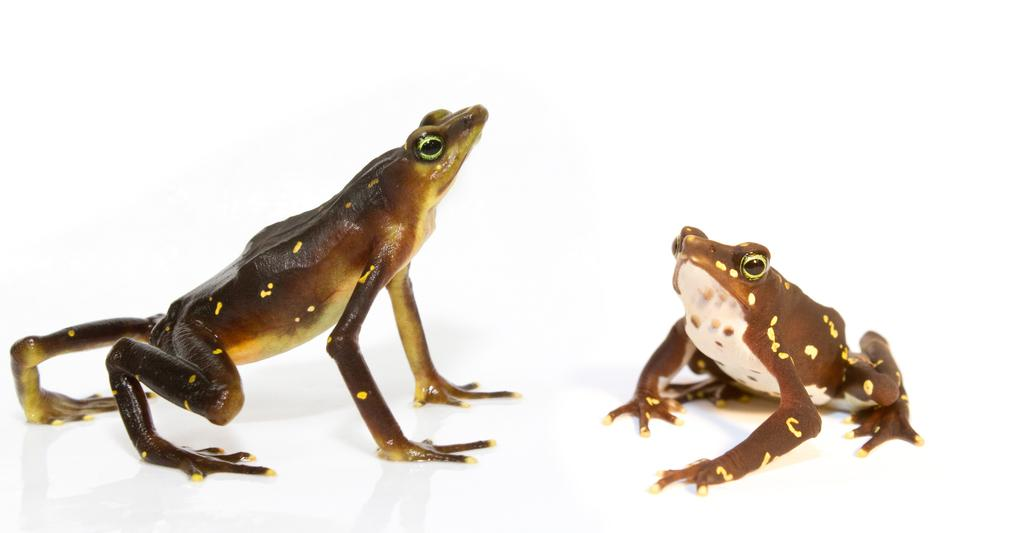What type of objects are present in the image that resemble drugs? There are two objects in the image that resemble drugs. What is the color of the objects that resemble drugs? The objects that resemble drugs are brown in color. On what surface are the objects that resemble drugs placed? The objects that resemble drugs are on a white colored surface. What is the color of the background in the image? The background of the image is white. What type of hen can be seen in the image? There is no hen present in the image. What type of knowledge is being shared in the image? There is no knowledge being shared in the image; it features objects that resemble drugs on a white surface. 